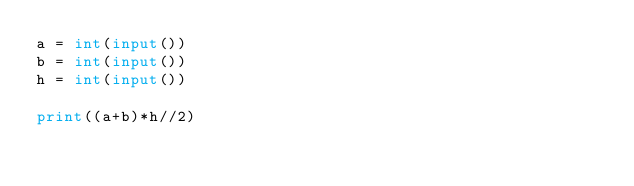<code> <loc_0><loc_0><loc_500><loc_500><_Python_>a = int(input())
b = int(input())
h = int(input())

print((a+b)*h//2)</code> 